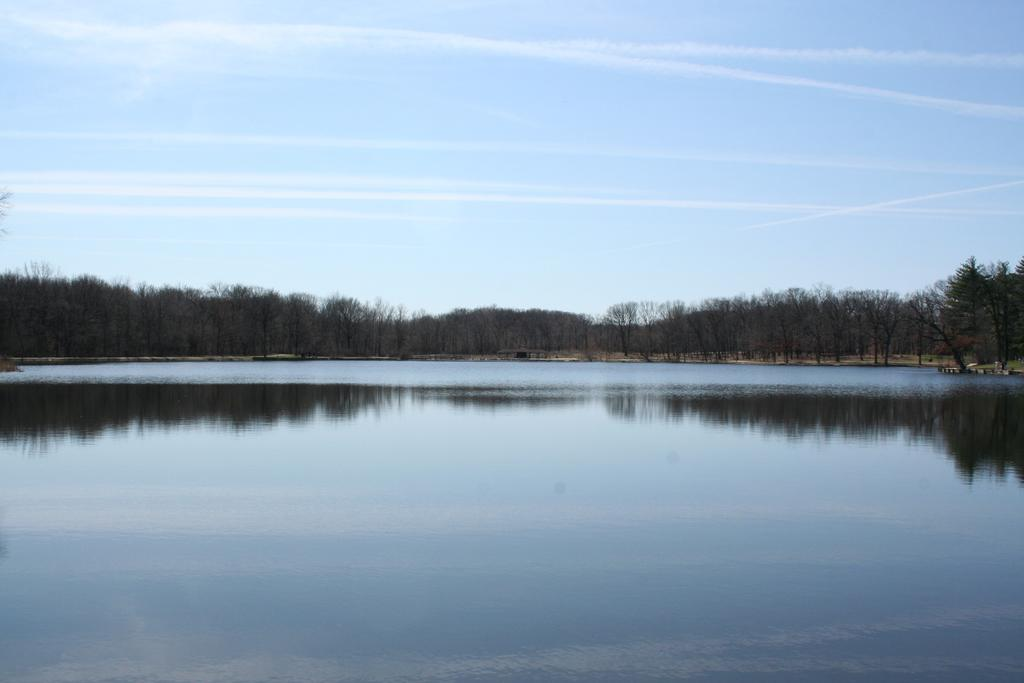What type of body of water is in the image? There is a lake in the image. What type of vegetation can be seen in the image? There are trees in the image. What part of the natural environment is visible in the image? The sky is visible in the image. What can be seen in the sky in the image? Clouds are present in the sky. How does the tooth compare to the size of the lake in the image? There is no tooth present in the image, so it cannot be compared to the size of the lake. 